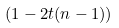<formula> <loc_0><loc_0><loc_500><loc_500>( 1 - 2 t ( n - 1 ) )</formula> 